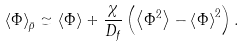<formula> <loc_0><loc_0><loc_500><loc_500>\left \langle \Phi \right \rangle _ { \bar { \rho } } \simeq \langle \Phi \rangle + \frac { \chi } { D _ { f } } \left ( \left \langle \Phi ^ { 2 } \right \rangle - { \left \langle \Phi \right \rangle } ^ { 2 } \right ) .</formula> 